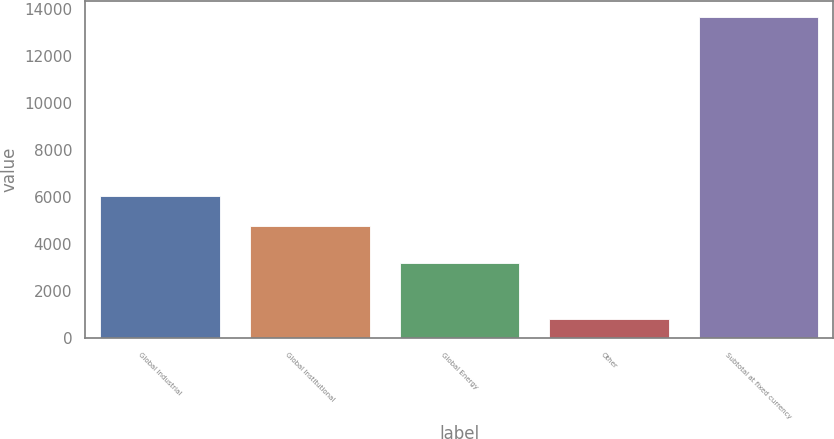<chart> <loc_0><loc_0><loc_500><loc_500><bar_chart><fcel>Global Industrial<fcel>Global Institutional<fcel>Global Energy<fcel>Other<fcel>Subtotal at fixed currency<nl><fcel>6027.17<fcel>4744.9<fcel>3199.3<fcel>823.5<fcel>13646.2<nl></chart> 